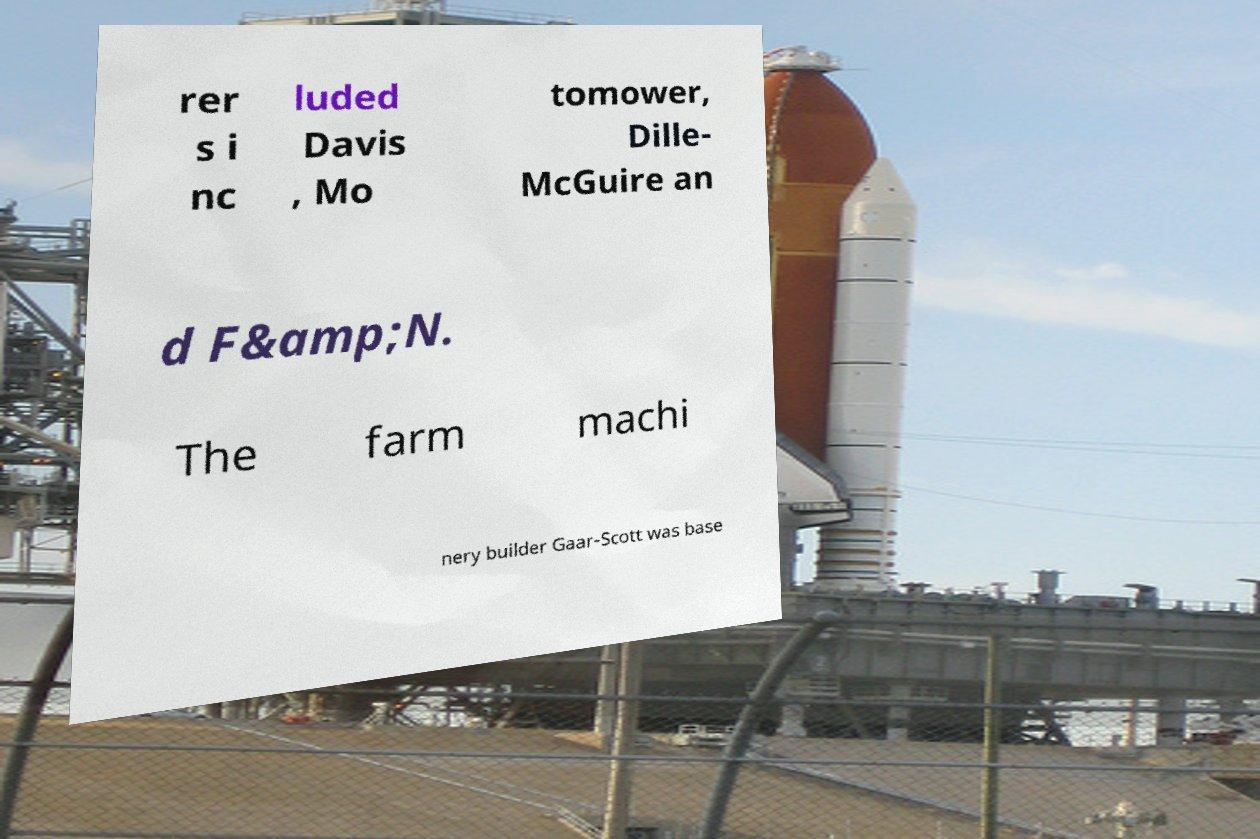Can you read and provide the text displayed in the image?This photo seems to have some interesting text. Can you extract and type it out for me? rer s i nc luded Davis , Mo tomower, Dille- McGuire an d F&amp;N. The farm machi nery builder Gaar-Scott was base 